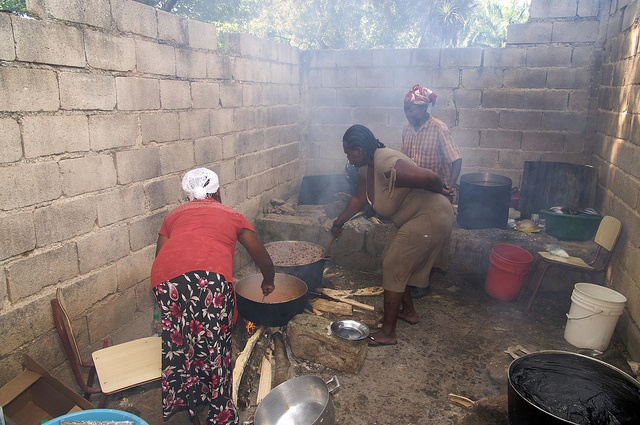Describe the objects in this image and their specific colors. I can see people in teal, black, brown, and gray tones, people in teal, gray, and black tones, chair in teal, tan, maroon, and gray tones, chair in teal, black, maroon, and gray tones, and people in teal, darkgray, and gray tones in this image. 